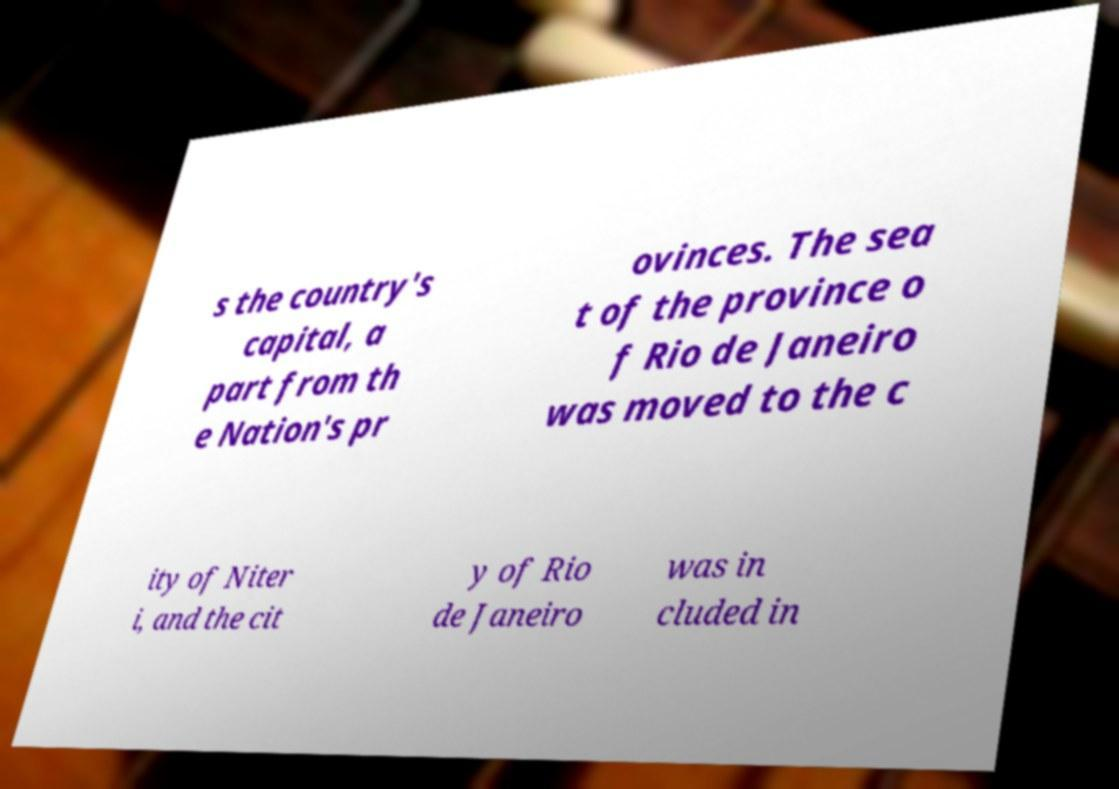There's text embedded in this image that I need extracted. Can you transcribe it verbatim? s the country's capital, a part from th e Nation's pr ovinces. The sea t of the province o f Rio de Janeiro was moved to the c ity of Niter i, and the cit y of Rio de Janeiro was in cluded in 